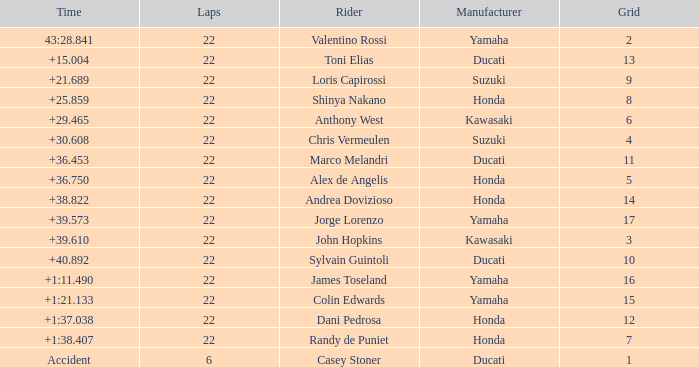What grid is Ducati with fewer than 22 laps? 1.0. 